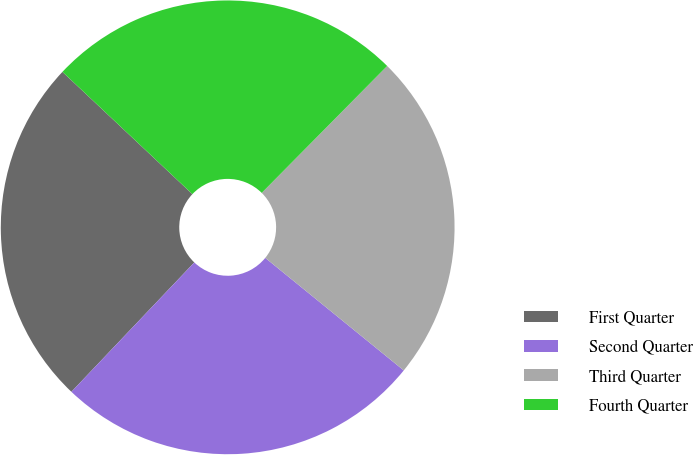<chart> <loc_0><loc_0><loc_500><loc_500><pie_chart><fcel>First Quarter<fcel>Second Quarter<fcel>Third Quarter<fcel>Fourth Quarter<nl><fcel>24.92%<fcel>26.23%<fcel>23.45%<fcel>25.39%<nl></chart> 